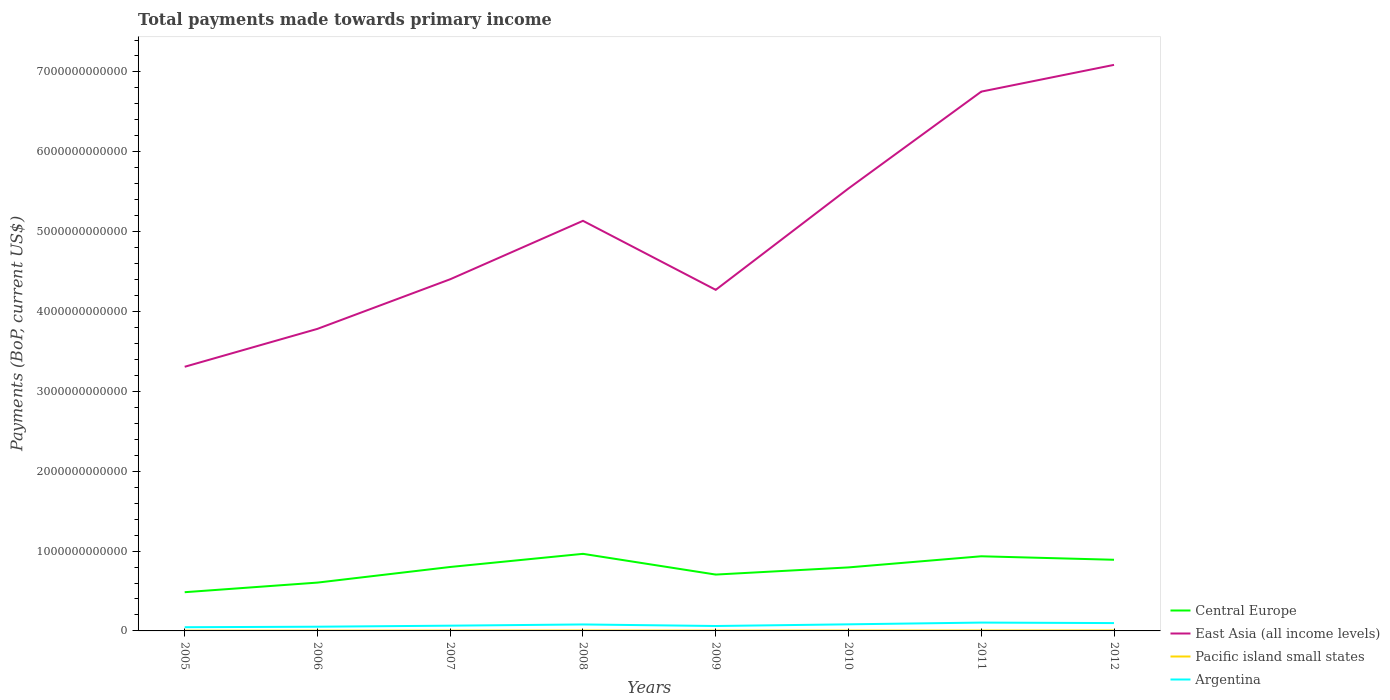Is the number of lines equal to the number of legend labels?
Make the answer very short. Yes. Across all years, what is the maximum total payments made towards primary income in Central Europe?
Offer a terse response. 4.85e+11. What is the total total payments made towards primary income in Pacific island small states in the graph?
Give a very brief answer. -1.23e+09. What is the difference between the highest and the second highest total payments made towards primary income in East Asia (all income levels)?
Your answer should be compact. 3.78e+12. What is the difference between two consecutive major ticks on the Y-axis?
Make the answer very short. 1.00e+12. Are the values on the major ticks of Y-axis written in scientific E-notation?
Your answer should be compact. No. Does the graph contain grids?
Provide a succinct answer. No. How many legend labels are there?
Make the answer very short. 4. What is the title of the graph?
Ensure brevity in your answer.  Total payments made towards primary income. Does "Cambodia" appear as one of the legend labels in the graph?
Make the answer very short. No. What is the label or title of the Y-axis?
Give a very brief answer. Payments (BoP, current US$). What is the Payments (BoP, current US$) in Central Europe in 2005?
Make the answer very short. 4.85e+11. What is the Payments (BoP, current US$) in East Asia (all income levels) in 2005?
Provide a short and direct response. 3.31e+12. What is the Payments (BoP, current US$) of Pacific island small states in 2005?
Provide a succinct answer. 3.59e+09. What is the Payments (BoP, current US$) of Argentina in 2005?
Offer a terse response. 4.64e+1. What is the Payments (BoP, current US$) in Central Europe in 2006?
Your answer should be very brief. 6.05e+11. What is the Payments (BoP, current US$) of East Asia (all income levels) in 2006?
Provide a succinct answer. 3.78e+12. What is the Payments (BoP, current US$) in Pacific island small states in 2006?
Make the answer very short. 3.94e+09. What is the Payments (BoP, current US$) of Argentina in 2006?
Your answer should be very brief. 5.28e+1. What is the Payments (BoP, current US$) of Central Europe in 2007?
Your response must be concise. 8.01e+11. What is the Payments (BoP, current US$) of East Asia (all income levels) in 2007?
Ensure brevity in your answer.  4.40e+12. What is the Payments (BoP, current US$) of Pacific island small states in 2007?
Provide a succinct answer. 4.20e+09. What is the Payments (BoP, current US$) of Argentina in 2007?
Offer a very short reply. 6.58e+1. What is the Payments (BoP, current US$) in Central Europe in 2008?
Your answer should be compact. 9.65e+11. What is the Payments (BoP, current US$) in East Asia (all income levels) in 2008?
Offer a terse response. 5.14e+12. What is the Payments (BoP, current US$) of Pacific island small states in 2008?
Give a very brief answer. 5.17e+09. What is the Payments (BoP, current US$) in Argentina in 2008?
Give a very brief answer. 8.10e+1. What is the Payments (BoP, current US$) in Central Europe in 2009?
Your answer should be compact. 7.06e+11. What is the Payments (BoP, current US$) in East Asia (all income levels) in 2009?
Provide a succinct answer. 4.27e+12. What is the Payments (BoP, current US$) in Pacific island small states in 2009?
Make the answer very short. 3.87e+09. What is the Payments (BoP, current US$) in Argentina in 2009?
Give a very brief answer. 6.17e+1. What is the Payments (BoP, current US$) in Central Europe in 2010?
Give a very brief answer. 7.95e+11. What is the Payments (BoP, current US$) of East Asia (all income levels) in 2010?
Offer a terse response. 5.54e+12. What is the Payments (BoP, current US$) in Pacific island small states in 2010?
Your answer should be compact. 4.63e+09. What is the Payments (BoP, current US$) of Argentina in 2010?
Offer a very short reply. 8.26e+1. What is the Payments (BoP, current US$) of Central Europe in 2011?
Keep it short and to the point. 9.35e+11. What is the Payments (BoP, current US$) of East Asia (all income levels) in 2011?
Offer a terse response. 6.75e+12. What is the Payments (BoP, current US$) of Pacific island small states in 2011?
Ensure brevity in your answer.  5.43e+09. What is the Payments (BoP, current US$) of Argentina in 2011?
Ensure brevity in your answer.  1.04e+11. What is the Payments (BoP, current US$) in Central Europe in 2012?
Offer a very short reply. 8.91e+11. What is the Payments (BoP, current US$) in East Asia (all income levels) in 2012?
Your answer should be compact. 7.09e+12. What is the Payments (BoP, current US$) of Pacific island small states in 2012?
Make the answer very short. 5.60e+09. What is the Payments (BoP, current US$) of Argentina in 2012?
Keep it short and to the point. 9.83e+1. Across all years, what is the maximum Payments (BoP, current US$) of Central Europe?
Ensure brevity in your answer.  9.65e+11. Across all years, what is the maximum Payments (BoP, current US$) in East Asia (all income levels)?
Your answer should be very brief. 7.09e+12. Across all years, what is the maximum Payments (BoP, current US$) in Pacific island small states?
Keep it short and to the point. 5.60e+09. Across all years, what is the maximum Payments (BoP, current US$) in Argentina?
Offer a terse response. 1.04e+11. Across all years, what is the minimum Payments (BoP, current US$) in Central Europe?
Offer a terse response. 4.85e+11. Across all years, what is the minimum Payments (BoP, current US$) in East Asia (all income levels)?
Ensure brevity in your answer.  3.31e+12. Across all years, what is the minimum Payments (BoP, current US$) in Pacific island small states?
Your response must be concise. 3.59e+09. Across all years, what is the minimum Payments (BoP, current US$) in Argentina?
Make the answer very short. 4.64e+1. What is the total Payments (BoP, current US$) of Central Europe in the graph?
Ensure brevity in your answer.  6.18e+12. What is the total Payments (BoP, current US$) in East Asia (all income levels) in the graph?
Provide a succinct answer. 4.03e+13. What is the total Payments (BoP, current US$) of Pacific island small states in the graph?
Offer a terse response. 3.64e+1. What is the total Payments (BoP, current US$) in Argentina in the graph?
Your answer should be very brief. 5.93e+11. What is the difference between the Payments (BoP, current US$) of Central Europe in 2005 and that in 2006?
Your answer should be very brief. -1.20e+11. What is the difference between the Payments (BoP, current US$) in East Asia (all income levels) in 2005 and that in 2006?
Your answer should be very brief. -4.75e+11. What is the difference between the Payments (BoP, current US$) of Pacific island small states in 2005 and that in 2006?
Offer a very short reply. -3.57e+08. What is the difference between the Payments (BoP, current US$) in Argentina in 2005 and that in 2006?
Your answer should be very brief. -6.39e+09. What is the difference between the Payments (BoP, current US$) of Central Europe in 2005 and that in 2007?
Your answer should be very brief. -3.16e+11. What is the difference between the Payments (BoP, current US$) of East Asia (all income levels) in 2005 and that in 2007?
Your answer should be very brief. -1.10e+12. What is the difference between the Payments (BoP, current US$) of Pacific island small states in 2005 and that in 2007?
Your answer should be compact. -6.11e+08. What is the difference between the Payments (BoP, current US$) in Argentina in 2005 and that in 2007?
Your answer should be very brief. -1.94e+1. What is the difference between the Payments (BoP, current US$) of Central Europe in 2005 and that in 2008?
Keep it short and to the point. -4.80e+11. What is the difference between the Payments (BoP, current US$) of East Asia (all income levels) in 2005 and that in 2008?
Offer a very short reply. -1.83e+12. What is the difference between the Payments (BoP, current US$) of Pacific island small states in 2005 and that in 2008?
Ensure brevity in your answer.  -1.58e+09. What is the difference between the Payments (BoP, current US$) in Argentina in 2005 and that in 2008?
Give a very brief answer. -3.46e+1. What is the difference between the Payments (BoP, current US$) of Central Europe in 2005 and that in 2009?
Provide a succinct answer. -2.21e+11. What is the difference between the Payments (BoP, current US$) of East Asia (all income levels) in 2005 and that in 2009?
Ensure brevity in your answer.  -9.63e+11. What is the difference between the Payments (BoP, current US$) of Pacific island small states in 2005 and that in 2009?
Provide a succinct answer. -2.79e+08. What is the difference between the Payments (BoP, current US$) in Argentina in 2005 and that in 2009?
Your answer should be very brief. -1.53e+1. What is the difference between the Payments (BoP, current US$) in Central Europe in 2005 and that in 2010?
Offer a very short reply. -3.10e+11. What is the difference between the Payments (BoP, current US$) in East Asia (all income levels) in 2005 and that in 2010?
Give a very brief answer. -2.23e+12. What is the difference between the Payments (BoP, current US$) in Pacific island small states in 2005 and that in 2010?
Ensure brevity in your answer.  -1.04e+09. What is the difference between the Payments (BoP, current US$) in Argentina in 2005 and that in 2010?
Offer a terse response. -3.62e+1. What is the difference between the Payments (BoP, current US$) in Central Europe in 2005 and that in 2011?
Offer a very short reply. -4.50e+11. What is the difference between the Payments (BoP, current US$) in East Asia (all income levels) in 2005 and that in 2011?
Keep it short and to the point. -3.45e+12. What is the difference between the Payments (BoP, current US$) in Pacific island small states in 2005 and that in 2011?
Your answer should be compact. -1.84e+09. What is the difference between the Payments (BoP, current US$) in Argentina in 2005 and that in 2011?
Your response must be concise. -5.80e+1. What is the difference between the Payments (BoP, current US$) of Central Europe in 2005 and that in 2012?
Ensure brevity in your answer.  -4.06e+11. What is the difference between the Payments (BoP, current US$) of East Asia (all income levels) in 2005 and that in 2012?
Offer a very short reply. -3.78e+12. What is the difference between the Payments (BoP, current US$) in Pacific island small states in 2005 and that in 2012?
Your answer should be compact. -2.02e+09. What is the difference between the Payments (BoP, current US$) of Argentina in 2005 and that in 2012?
Provide a short and direct response. -5.19e+1. What is the difference between the Payments (BoP, current US$) of Central Europe in 2006 and that in 2007?
Your answer should be very brief. -1.96e+11. What is the difference between the Payments (BoP, current US$) of East Asia (all income levels) in 2006 and that in 2007?
Ensure brevity in your answer.  -6.21e+11. What is the difference between the Payments (BoP, current US$) in Pacific island small states in 2006 and that in 2007?
Your answer should be compact. -2.54e+08. What is the difference between the Payments (BoP, current US$) of Argentina in 2006 and that in 2007?
Give a very brief answer. -1.30e+1. What is the difference between the Payments (BoP, current US$) of Central Europe in 2006 and that in 2008?
Ensure brevity in your answer.  -3.60e+11. What is the difference between the Payments (BoP, current US$) of East Asia (all income levels) in 2006 and that in 2008?
Offer a very short reply. -1.35e+12. What is the difference between the Payments (BoP, current US$) in Pacific island small states in 2006 and that in 2008?
Offer a very short reply. -1.22e+09. What is the difference between the Payments (BoP, current US$) in Argentina in 2006 and that in 2008?
Give a very brief answer. -2.82e+1. What is the difference between the Payments (BoP, current US$) of Central Europe in 2006 and that in 2009?
Keep it short and to the point. -1.01e+11. What is the difference between the Payments (BoP, current US$) of East Asia (all income levels) in 2006 and that in 2009?
Offer a terse response. -4.89e+11. What is the difference between the Payments (BoP, current US$) in Pacific island small states in 2006 and that in 2009?
Your answer should be compact. 7.80e+07. What is the difference between the Payments (BoP, current US$) in Argentina in 2006 and that in 2009?
Provide a succinct answer. -8.90e+09. What is the difference between the Payments (BoP, current US$) of Central Europe in 2006 and that in 2010?
Offer a very short reply. -1.90e+11. What is the difference between the Payments (BoP, current US$) of East Asia (all income levels) in 2006 and that in 2010?
Ensure brevity in your answer.  -1.76e+12. What is the difference between the Payments (BoP, current US$) of Pacific island small states in 2006 and that in 2010?
Your response must be concise. -6.84e+08. What is the difference between the Payments (BoP, current US$) of Argentina in 2006 and that in 2010?
Offer a very short reply. -2.98e+1. What is the difference between the Payments (BoP, current US$) of Central Europe in 2006 and that in 2011?
Offer a terse response. -3.30e+11. What is the difference between the Payments (BoP, current US$) in East Asia (all income levels) in 2006 and that in 2011?
Provide a succinct answer. -2.97e+12. What is the difference between the Payments (BoP, current US$) of Pacific island small states in 2006 and that in 2011?
Give a very brief answer. -1.48e+09. What is the difference between the Payments (BoP, current US$) in Argentina in 2006 and that in 2011?
Offer a terse response. -5.16e+1. What is the difference between the Payments (BoP, current US$) of Central Europe in 2006 and that in 2012?
Give a very brief answer. -2.86e+11. What is the difference between the Payments (BoP, current US$) of East Asia (all income levels) in 2006 and that in 2012?
Offer a terse response. -3.31e+12. What is the difference between the Payments (BoP, current US$) in Pacific island small states in 2006 and that in 2012?
Give a very brief answer. -1.66e+09. What is the difference between the Payments (BoP, current US$) in Argentina in 2006 and that in 2012?
Your answer should be compact. -4.55e+1. What is the difference between the Payments (BoP, current US$) of Central Europe in 2007 and that in 2008?
Offer a terse response. -1.65e+11. What is the difference between the Payments (BoP, current US$) of East Asia (all income levels) in 2007 and that in 2008?
Offer a very short reply. -7.32e+11. What is the difference between the Payments (BoP, current US$) in Pacific island small states in 2007 and that in 2008?
Ensure brevity in your answer.  -9.70e+08. What is the difference between the Payments (BoP, current US$) in Argentina in 2007 and that in 2008?
Provide a short and direct response. -1.52e+1. What is the difference between the Payments (BoP, current US$) of Central Europe in 2007 and that in 2009?
Offer a terse response. 9.51e+1. What is the difference between the Payments (BoP, current US$) of East Asia (all income levels) in 2007 and that in 2009?
Offer a very short reply. 1.33e+11. What is the difference between the Payments (BoP, current US$) in Pacific island small states in 2007 and that in 2009?
Give a very brief answer. 3.32e+08. What is the difference between the Payments (BoP, current US$) in Argentina in 2007 and that in 2009?
Give a very brief answer. 4.09e+09. What is the difference between the Payments (BoP, current US$) in Central Europe in 2007 and that in 2010?
Keep it short and to the point. 5.46e+09. What is the difference between the Payments (BoP, current US$) of East Asia (all income levels) in 2007 and that in 2010?
Give a very brief answer. -1.14e+12. What is the difference between the Payments (BoP, current US$) of Pacific island small states in 2007 and that in 2010?
Your response must be concise. -4.30e+08. What is the difference between the Payments (BoP, current US$) in Argentina in 2007 and that in 2010?
Provide a succinct answer. -1.68e+1. What is the difference between the Payments (BoP, current US$) of Central Europe in 2007 and that in 2011?
Offer a very short reply. -1.34e+11. What is the difference between the Payments (BoP, current US$) of East Asia (all income levels) in 2007 and that in 2011?
Offer a terse response. -2.35e+12. What is the difference between the Payments (BoP, current US$) in Pacific island small states in 2007 and that in 2011?
Ensure brevity in your answer.  -1.23e+09. What is the difference between the Payments (BoP, current US$) in Argentina in 2007 and that in 2011?
Offer a very short reply. -3.86e+1. What is the difference between the Payments (BoP, current US$) in Central Europe in 2007 and that in 2012?
Give a very brief answer. -9.03e+1. What is the difference between the Payments (BoP, current US$) of East Asia (all income levels) in 2007 and that in 2012?
Make the answer very short. -2.68e+12. What is the difference between the Payments (BoP, current US$) in Pacific island small states in 2007 and that in 2012?
Offer a terse response. -1.41e+09. What is the difference between the Payments (BoP, current US$) in Argentina in 2007 and that in 2012?
Ensure brevity in your answer.  -3.25e+1. What is the difference between the Payments (BoP, current US$) of Central Europe in 2008 and that in 2009?
Offer a very short reply. 2.60e+11. What is the difference between the Payments (BoP, current US$) of East Asia (all income levels) in 2008 and that in 2009?
Offer a terse response. 8.64e+11. What is the difference between the Payments (BoP, current US$) in Pacific island small states in 2008 and that in 2009?
Ensure brevity in your answer.  1.30e+09. What is the difference between the Payments (BoP, current US$) in Argentina in 2008 and that in 2009?
Your answer should be compact. 1.93e+1. What is the difference between the Payments (BoP, current US$) of Central Europe in 2008 and that in 2010?
Your answer should be compact. 1.70e+11. What is the difference between the Payments (BoP, current US$) of East Asia (all income levels) in 2008 and that in 2010?
Give a very brief answer. -4.05e+11. What is the difference between the Payments (BoP, current US$) in Pacific island small states in 2008 and that in 2010?
Make the answer very short. 5.40e+08. What is the difference between the Payments (BoP, current US$) in Argentina in 2008 and that in 2010?
Ensure brevity in your answer.  -1.59e+09. What is the difference between the Payments (BoP, current US$) in Central Europe in 2008 and that in 2011?
Provide a succinct answer. 3.06e+1. What is the difference between the Payments (BoP, current US$) in East Asia (all income levels) in 2008 and that in 2011?
Your answer should be compact. -1.62e+12. What is the difference between the Payments (BoP, current US$) in Pacific island small states in 2008 and that in 2011?
Make the answer very short. -2.60e+08. What is the difference between the Payments (BoP, current US$) in Argentina in 2008 and that in 2011?
Provide a short and direct response. -2.34e+1. What is the difference between the Payments (BoP, current US$) of Central Europe in 2008 and that in 2012?
Offer a very short reply. 7.43e+1. What is the difference between the Payments (BoP, current US$) in East Asia (all income levels) in 2008 and that in 2012?
Ensure brevity in your answer.  -1.95e+12. What is the difference between the Payments (BoP, current US$) in Pacific island small states in 2008 and that in 2012?
Ensure brevity in your answer.  -4.36e+08. What is the difference between the Payments (BoP, current US$) of Argentina in 2008 and that in 2012?
Your response must be concise. -1.73e+1. What is the difference between the Payments (BoP, current US$) in Central Europe in 2009 and that in 2010?
Your answer should be compact. -8.97e+1. What is the difference between the Payments (BoP, current US$) in East Asia (all income levels) in 2009 and that in 2010?
Keep it short and to the point. -1.27e+12. What is the difference between the Payments (BoP, current US$) of Pacific island small states in 2009 and that in 2010?
Your answer should be very brief. -7.62e+08. What is the difference between the Payments (BoP, current US$) in Argentina in 2009 and that in 2010?
Provide a short and direct response. -2.09e+1. What is the difference between the Payments (BoP, current US$) in Central Europe in 2009 and that in 2011?
Provide a succinct answer. -2.29e+11. What is the difference between the Payments (BoP, current US$) in East Asia (all income levels) in 2009 and that in 2011?
Provide a short and direct response. -2.48e+12. What is the difference between the Payments (BoP, current US$) of Pacific island small states in 2009 and that in 2011?
Your answer should be compact. -1.56e+09. What is the difference between the Payments (BoP, current US$) of Argentina in 2009 and that in 2011?
Offer a terse response. -4.27e+1. What is the difference between the Payments (BoP, current US$) in Central Europe in 2009 and that in 2012?
Give a very brief answer. -1.85e+11. What is the difference between the Payments (BoP, current US$) in East Asia (all income levels) in 2009 and that in 2012?
Make the answer very short. -2.82e+12. What is the difference between the Payments (BoP, current US$) in Pacific island small states in 2009 and that in 2012?
Make the answer very short. -1.74e+09. What is the difference between the Payments (BoP, current US$) in Argentina in 2009 and that in 2012?
Your answer should be very brief. -3.66e+1. What is the difference between the Payments (BoP, current US$) of Central Europe in 2010 and that in 2011?
Offer a very short reply. -1.39e+11. What is the difference between the Payments (BoP, current US$) in East Asia (all income levels) in 2010 and that in 2011?
Ensure brevity in your answer.  -1.21e+12. What is the difference between the Payments (BoP, current US$) in Pacific island small states in 2010 and that in 2011?
Keep it short and to the point. -8.00e+08. What is the difference between the Payments (BoP, current US$) of Argentina in 2010 and that in 2011?
Give a very brief answer. -2.18e+1. What is the difference between the Payments (BoP, current US$) in Central Europe in 2010 and that in 2012?
Provide a short and direct response. -9.57e+1. What is the difference between the Payments (BoP, current US$) in East Asia (all income levels) in 2010 and that in 2012?
Make the answer very short. -1.55e+12. What is the difference between the Payments (BoP, current US$) of Pacific island small states in 2010 and that in 2012?
Your answer should be very brief. -9.76e+08. What is the difference between the Payments (BoP, current US$) of Argentina in 2010 and that in 2012?
Your answer should be very brief. -1.57e+1. What is the difference between the Payments (BoP, current US$) in Central Europe in 2011 and that in 2012?
Keep it short and to the point. 4.37e+1. What is the difference between the Payments (BoP, current US$) in East Asia (all income levels) in 2011 and that in 2012?
Offer a terse response. -3.35e+11. What is the difference between the Payments (BoP, current US$) of Pacific island small states in 2011 and that in 2012?
Provide a succinct answer. -1.75e+08. What is the difference between the Payments (BoP, current US$) of Argentina in 2011 and that in 2012?
Provide a succinct answer. 6.14e+09. What is the difference between the Payments (BoP, current US$) in Central Europe in 2005 and the Payments (BoP, current US$) in East Asia (all income levels) in 2006?
Give a very brief answer. -3.30e+12. What is the difference between the Payments (BoP, current US$) of Central Europe in 2005 and the Payments (BoP, current US$) of Pacific island small states in 2006?
Your response must be concise. 4.81e+11. What is the difference between the Payments (BoP, current US$) in Central Europe in 2005 and the Payments (BoP, current US$) in Argentina in 2006?
Your answer should be very brief. 4.32e+11. What is the difference between the Payments (BoP, current US$) in East Asia (all income levels) in 2005 and the Payments (BoP, current US$) in Pacific island small states in 2006?
Offer a very short reply. 3.30e+12. What is the difference between the Payments (BoP, current US$) of East Asia (all income levels) in 2005 and the Payments (BoP, current US$) of Argentina in 2006?
Your response must be concise. 3.26e+12. What is the difference between the Payments (BoP, current US$) of Pacific island small states in 2005 and the Payments (BoP, current US$) of Argentina in 2006?
Your answer should be compact. -4.92e+1. What is the difference between the Payments (BoP, current US$) of Central Europe in 2005 and the Payments (BoP, current US$) of East Asia (all income levels) in 2007?
Ensure brevity in your answer.  -3.92e+12. What is the difference between the Payments (BoP, current US$) in Central Europe in 2005 and the Payments (BoP, current US$) in Pacific island small states in 2007?
Provide a short and direct response. 4.81e+11. What is the difference between the Payments (BoP, current US$) of Central Europe in 2005 and the Payments (BoP, current US$) of Argentina in 2007?
Provide a short and direct response. 4.19e+11. What is the difference between the Payments (BoP, current US$) of East Asia (all income levels) in 2005 and the Payments (BoP, current US$) of Pacific island small states in 2007?
Offer a very short reply. 3.30e+12. What is the difference between the Payments (BoP, current US$) of East Asia (all income levels) in 2005 and the Payments (BoP, current US$) of Argentina in 2007?
Ensure brevity in your answer.  3.24e+12. What is the difference between the Payments (BoP, current US$) of Pacific island small states in 2005 and the Payments (BoP, current US$) of Argentina in 2007?
Provide a short and direct response. -6.22e+1. What is the difference between the Payments (BoP, current US$) in Central Europe in 2005 and the Payments (BoP, current US$) in East Asia (all income levels) in 2008?
Your answer should be compact. -4.65e+12. What is the difference between the Payments (BoP, current US$) of Central Europe in 2005 and the Payments (BoP, current US$) of Pacific island small states in 2008?
Your response must be concise. 4.80e+11. What is the difference between the Payments (BoP, current US$) of Central Europe in 2005 and the Payments (BoP, current US$) of Argentina in 2008?
Provide a succinct answer. 4.04e+11. What is the difference between the Payments (BoP, current US$) in East Asia (all income levels) in 2005 and the Payments (BoP, current US$) in Pacific island small states in 2008?
Ensure brevity in your answer.  3.30e+12. What is the difference between the Payments (BoP, current US$) of East Asia (all income levels) in 2005 and the Payments (BoP, current US$) of Argentina in 2008?
Make the answer very short. 3.23e+12. What is the difference between the Payments (BoP, current US$) of Pacific island small states in 2005 and the Payments (BoP, current US$) of Argentina in 2008?
Give a very brief answer. -7.74e+1. What is the difference between the Payments (BoP, current US$) in Central Europe in 2005 and the Payments (BoP, current US$) in East Asia (all income levels) in 2009?
Ensure brevity in your answer.  -3.79e+12. What is the difference between the Payments (BoP, current US$) of Central Europe in 2005 and the Payments (BoP, current US$) of Pacific island small states in 2009?
Offer a very short reply. 4.81e+11. What is the difference between the Payments (BoP, current US$) in Central Europe in 2005 and the Payments (BoP, current US$) in Argentina in 2009?
Offer a terse response. 4.23e+11. What is the difference between the Payments (BoP, current US$) of East Asia (all income levels) in 2005 and the Payments (BoP, current US$) of Pacific island small states in 2009?
Your answer should be compact. 3.30e+12. What is the difference between the Payments (BoP, current US$) in East Asia (all income levels) in 2005 and the Payments (BoP, current US$) in Argentina in 2009?
Your answer should be very brief. 3.25e+12. What is the difference between the Payments (BoP, current US$) of Pacific island small states in 2005 and the Payments (BoP, current US$) of Argentina in 2009?
Your answer should be compact. -5.81e+1. What is the difference between the Payments (BoP, current US$) of Central Europe in 2005 and the Payments (BoP, current US$) of East Asia (all income levels) in 2010?
Keep it short and to the point. -5.06e+12. What is the difference between the Payments (BoP, current US$) in Central Europe in 2005 and the Payments (BoP, current US$) in Pacific island small states in 2010?
Provide a succinct answer. 4.80e+11. What is the difference between the Payments (BoP, current US$) in Central Europe in 2005 and the Payments (BoP, current US$) in Argentina in 2010?
Your answer should be compact. 4.02e+11. What is the difference between the Payments (BoP, current US$) of East Asia (all income levels) in 2005 and the Payments (BoP, current US$) of Pacific island small states in 2010?
Ensure brevity in your answer.  3.30e+12. What is the difference between the Payments (BoP, current US$) in East Asia (all income levels) in 2005 and the Payments (BoP, current US$) in Argentina in 2010?
Give a very brief answer. 3.23e+12. What is the difference between the Payments (BoP, current US$) of Pacific island small states in 2005 and the Payments (BoP, current US$) of Argentina in 2010?
Your answer should be very brief. -7.90e+1. What is the difference between the Payments (BoP, current US$) in Central Europe in 2005 and the Payments (BoP, current US$) in East Asia (all income levels) in 2011?
Give a very brief answer. -6.27e+12. What is the difference between the Payments (BoP, current US$) in Central Europe in 2005 and the Payments (BoP, current US$) in Pacific island small states in 2011?
Your response must be concise. 4.79e+11. What is the difference between the Payments (BoP, current US$) in Central Europe in 2005 and the Payments (BoP, current US$) in Argentina in 2011?
Offer a terse response. 3.80e+11. What is the difference between the Payments (BoP, current US$) in East Asia (all income levels) in 2005 and the Payments (BoP, current US$) in Pacific island small states in 2011?
Offer a terse response. 3.30e+12. What is the difference between the Payments (BoP, current US$) of East Asia (all income levels) in 2005 and the Payments (BoP, current US$) of Argentina in 2011?
Offer a very short reply. 3.20e+12. What is the difference between the Payments (BoP, current US$) of Pacific island small states in 2005 and the Payments (BoP, current US$) of Argentina in 2011?
Your response must be concise. -1.01e+11. What is the difference between the Payments (BoP, current US$) of Central Europe in 2005 and the Payments (BoP, current US$) of East Asia (all income levels) in 2012?
Give a very brief answer. -6.60e+12. What is the difference between the Payments (BoP, current US$) of Central Europe in 2005 and the Payments (BoP, current US$) of Pacific island small states in 2012?
Make the answer very short. 4.79e+11. What is the difference between the Payments (BoP, current US$) in Central Europe in 2005 and the Payments (BoP, current US$) in Argentina in 2012?
Your response must be concise. 3.87e+11. What is the difference between the Payments (BoP, current US$) of East Asia (all income levels) in 2005 and the Payments (BoP, current US$) of Pacific island small states in 2012?
Your response must be concise. 3.30e+12. What is the difference between the Payments (BoP, current US$) in East Asia (all income levels) in 2005 and the Payments (BoP, current US$) in Argentina in 2012?
Your answer should be compact. 3.21e+12. What is the difference between the Payments (BoP, current US$) of Pacific island small states in 2005 and the Payments (BoP, current US$) of Argentina in 2012?
Provide a short and direct response. -9.47e+1. What is the difference between the Payments (BoP, current US$) of Central Europe in 2006 and the Payments (BoP, current US$) of East Asia (all income levels) in 2007?
Provide a succinct answer. -3.80e+12. What is the difference between the Payments (BoP, current US$) in Central Europe in 2006 and the Payments (BoP, current US$) in Pacific island small states in 2007?
Offer a very short reply. 6.01e+11. What is the difference between the Payments (BoP, current US$) in Central Europe in 2006 and the Payments (BoP, current US$) in Argentina in 2007?
Give a very brief answer. 5.39e+11. What is the difference between the Payments (BoP, current US$) of East Asia (all income levels) in 2006 and the Payments (BoP, current US$) of Pacific island small states in 2007?
Offer a very short reply. 3.78e+12. What is the difference between the Payments (BoP, current US$) of East Asia (all income levels) in 2006 and the Payments (BoP, current US$) of Argentina in 2007?
Your answer should be compact. 3.72e+12. What is the difference between the Payments (BoP, current US$) in Pacific island small states in 2006 and the Payments (BoP, current US$) in Argentina in 2007?
Offer a very short reply. -6.18e+1. What is the difference between the Payments (BoP, current US$) of Central Europe in 2006 and the Payments (BoP, current US$) of East Asia (all income levels) in 2008?
Offer a very short reply. -4.53e+12. What is the difference between the Payments (BoP, current US$) of Central Europe in 2006 and the Payments (BoP, current US$) of Pacific island small states in 2008?
Ensure brevity in your answer.  6.00e+11. What is the difference between the Payments (BoP, current US$) in Central Europe in 2006 and the Payments (BoP, current US$) in Argentina in 2008?
Make the answer very short. 5.24e+11. What is the difference between the Payments (BoP, current US$) in East Asia (all income levels) in 2006 and the Payments (BoP, current US$) in Pacific island small states in 2008?
Keep it short and to the point. 3.78e+12. What is the difference between the Payments (BoP, current US$) in East Asia (all income levels) in 2006 and the Payments (BoP, current US$) in Argentina in 2008?
Your answer should be very brief. 3.70e+12. What is the difference between the Payments (BoP, current US$) in Pacific island small states in 2006 and the Payments (BoP, current US$) in Argentina in 2008?
Provide a succinct answer. -7.71e+1. What is the difference between the Payments (BoP, current US$) of Central Europe in 2006 and the Payments (BoP, current US$) of East Asia (all income levels) in 2009?
Ensure brevity in your answer.  -3.67e+12. What is the difference between the Payments (BoP, current US$) in Central Europe in 2006 and the Payments (BoP, current US$) in Pacific island small states in 2009?
Ensure brevity in your answer.  6.01e+11. What is the difference between the Payments (BoP, current US$) in Central Europe in 2006 and the Payments (BoP, current US$) in Argentina in 2009?
Offer a terse response. 5.43e+11. What is the difference between the Payments (BoP, current US$) in East Asia (all income levels) in 2006 and the Payments (BoP, current US$) in Pacific island small states in 2009?
Provide a succinct answer. 3.78e+12. What is the difference between the Payments (BoP, current US$) in East Asia (all income levels) in 2006 and the Payments (BoP, current US$) in Argentina in 2009?
Your answer should be compact. 3.72e+12. What is the difference between the Payments (BoP, current US$) of Pacific island small states in 2006 and the Payments (BoP, current US$) of Argentina in 2009?
Give a very brief answer. -5.78e+1. What is the difference between the Payments (BoP, current US$) of Central Europe in 2006 and the Payments (BoP, current US$) of East Asia (all income levels) in 2010?
Offer a very short reply. -4.94e+12. What is the difference between the Payments (BoP, current US$) in Central Europe in 2006 and the Payments (BoP, current US$) in Pacific island small states in 2010?
Make the answer very short. 6.01e+11. What is the difference between the Payments (BoP, current US$) in Central Europe in 2006 and the Payments (BoP, current US$) in Argentina in 2010?
Make the answer very short. 5.23e+11. What is the difference between the Payments (BoP, current US$) in East Asia (all income levels) in 2006 and the Payments (BoP, current US$) in Pacific island small states in 2010?
Your answer should be very brief. 3.78e+12. What is the difference between the Payments (BoP, current US$) of East Asia (all income levels) in 2006 and the Payments (BoP, current US$) of Argentina in 2010?
Your answer should be very brief. 3.70e+12. What is the difference between the Payments (BoP, current US$) of Pacific island small states in 2006 and the Payments (BoP, current US$) of Argentina in 2010?
Provide a short and direct response. -7.87e+1. What is the difference between the Payments (BoP, current US$) in Central Europe in 2006 and the Payments (BoP, current US$) in East Asia (all income levels) in 2011?
Give a very brief answer. -6.15e+12. What is the difference between the Payments (BoP, current US$) of Central Europe in 2006 and the Payments (BoP, current US$) of Pacific island small states in 2011?
Your answer should be very brief. 6.00e+11. What is the difference between the Payments (BoP, current US$) of Central Europe in 2006 and the Payments (BoP, current US$) of Argentina in 2011?
Provide a short and direct response. 5.01e+11. What is the difference between the Payments (BoP, current US$) of East Asia (all income levels) in 2006 and the Payments (BoP, current US$) of Pacific island small states in 2011?
Your answer should be very brief. 3.78e+12. What is the difference between the Payments (BoP, current US$) of East Asia (all income levels) in 2006 and the Payments (BoP, current US$) of Argentina in 2011?
Give a very brief answer. 3.68e+12. What is the difference between the Payments (BoP, current US$) in Pacific island small states in 2006 and the Payments (BoP, current US$) in Argentina in 2011?
Offer a very short reply. -1.00e+11. What is the difference between the Payments (BoP, current US$) in Central Europe in 2006 and the Payments (BoP, current US$) in East Asia (all income levels) in 2012?
Provide a short and direct response. -6.48e+12. What is the difference between the Payments (BoP, current US$) of Central Europe in 2006 and the Payments (BoP, current US$) of Pacific island small states in 2012?
Offer a terse response. 6.00e+11. What is the difference between the Payments (BoP, current US$) in Central Europe in 2006 and the Payments (BoP, current US$) in Argentina in 2012?
Give a very brief answer. 5.07e+11. What is the difference between the Payments (BoP, current US$) in East Asia (all income levels) in 2006 and the Payments (BoP, current US$) in Pacific island small states in 2012?
Your answer should be compact. 3.78e+12. What is the difference between the Payments (BoP, current US$) of East Asia (all income levels) in 2006 and the Payments (BoP, current US$) of Argentina in 2012?
Keep it short and to the point. 3.68e+12. What is the difference between the Payments (BoP, current US$) in Pacific island small states in 2006 and the Payments (BoP, current US$) in Argentina in 2012?
Offer a very short reply. -9.43e+1. What is the difference between the Payments (BoP, current US$) of Central Europe in 2007 and the Payments (BoP, current US$) of East Asia (all income levels) in 2008?
Offer a very short reply. -4.33e+12. What is the difference between the Payments (BoP, current US$) in Central Europe in 2007 and the Payments (BoP, current US$) in Pacific island small states in 2008?
Provide a short and direct response. 7.96e+11. What is the difference between the Payments (BoP, current US$) in Central Europe in 2007 and the Payments (BoP, current US$) in Argentina in 2008?
Provide a short and direct response. 7.20e+11. What is the difference between the Payments (BoP, current US$) of East Asia (all income levels) in 2007 and the Payments (BoP, current US$) of Pacific island small states in 2008?
Give a very brief answer. 4.40e+12. What is the difference between the Payments (BoP, current US$) in East Asia (all income levels) in 2007 and the Payments (BoP, current US$) in Argentina in 2008?
Your answer should be very brief. 4.32e+12. What is the difference between the Payments (BoP, current US$) of Pacific island small states in 2007 and the Payments (BoP, current US$) of Argentina in 2008?
Provide a succinct answer. -7.68e+1. What is the difference between the Payments (BoP, current US$) in Central Europe in 2007 and the Payments (BoP, current US$) in East Asia (all income levels) in 2009?
Offer a terse response. -3.47e+12. What is the difference between the Payments (BoP, current US$) in Central Europe in 2007 and the Payments (BoP, current US$) in Pacific island small states in 2009?
Keep it short and to the point. 7.97e+11. What is the difference between the Payments (BoP, current US$) in Central Europe in 2007 and the Payments (BoP, current US$) in Argentina in 2009?
Provide a short and direct response. 7.39e+11. What is the difference between the Payments (BoP, current US$) of East Asia (all income levels) in 2007 and the Payments (BoP, current US$) of Pacific island small states in 2009?
Provide a succinct answer. 4.40e+12. What is the difference between the Payments (BoP, current US$) of East Asia (all income levels) in 2007 and the Payments (BoP, current US$) of Argentina in 2009?
Provide a succinct answer. 4.34e+12. What is the difference between the Payments (BoP, current US$) of Pacific island small states in 2007 and the Payments (BoP, current US$) of Argentina in 2009?
Provide a succinct answer. -5.75e+1. What is the difference between the Payments (BoP, current US$) of Central Europe in 2007 and the Payments (BoP, current US$) of East Asia (all income levels) in 2010?
Your answer should be very brief. -4.74e+12. What is the difference between the Payments (BoP, current US$) of Central Europe in 2007 and the Payments (BoP, current US$) of Pacific island small states in 2010?
Give a very brief answer. 7.96e+11. What is the difference between the Payments (BoP, current US$) in Central Europe in 2007 and the Payments (BoP, current US$) in Argentina in 2010?
Give a very brief answer. 7.18e+11. What is the difference between the Payments (BoP, current US$) in East Asia (all income levels) in 2007 and the Payments (BoP, current US$) in Pacific island small states in 2010?
Ensure brevity in your answer.  4.40e+12. What is the difference between the Payments (BoP, current US$) in East Asia (all income levels) in 2007 and the Payments (BoP, current US$) in Argentina in 2010?
Your answer should be compact. 4.32e+12. What is the difference between the Payments (BoP, current US$) in Pacific island small states in 2007 and the Payments (BoP, current US$) in Argentina in 2010?
Your answer should be compact. -7.84e+1. What is the difference between the Payments (BoP, current US$) of Central Europe in 2007 and the Payments (BoP, current US$) of East Asia (all income levels) in 2011?
Offer a very short reply. -5.95e+12. What is the difference between the Payments (BoP, current US$) in Central Europe in 2007 and the Payments (BoP, current US$) in Pacific island small states in 2011?
Offer a terse response. 7.95e+11. What is the difference between the Payments (BoP, current US$) of Central Europe in 2007 and the Payments (BoP, current US$) of Argentina in 2011?
Offer a terse response. 6.96e+11. What is the difference between the Payments (BoP, current US$) of East Asia (all income levels) in 2007 and the Payments (BoP, current US$) of Pacific island small states in 2011?
Your answer should be very brief. 4.40e+12. What is the difference between the Payments (BoP, current US$) of East Asia (all income levels) in 2007 and the Payments (BoP, current US$) of Argentina in 2011?
Offer a terse response. 4.30e+12. What is the difference between the Payments (BoP, current US$) of Pacific island small states in 2007 and the Payments (BoP, current US$) of Argentina in 2011?
Ensure brevity in your answer.  -1.00e+11. What is the difference between the Payments (BoP, current US$) of Central Europe in 2007 and the Payments (BoP, current US$) of East Asia (all income levels) in 2012?
Your response must be concise. -6.29e+12. What is the difference between the Payments (BoP, current US$) in Central Europe in 2007 and the Payments (BoP, current US$) in Pacific island small states in 2012?
Make the answer very short. 7.95e+11. What is the difference between the Payments (BoP, current US$) in Central Europe in 2007 and the Payments (BoP, current US$) in Argentina in 2012?
Make the answer very short. 7.03e+11. What is the difference between the Payments (BoP, current US$) of East Asia (all income levels) in 2007 and the Payments (BoP, current US$) of Pacific island small states in 2012?
Keep it short and to the point. 4.40e+12. What is the difference between the Payments (BoP, current US$) of East Asia (all income levels) in 2007 and the Payments (BoP, current US$) of Argentina in 2012?
Keep it short and to the point. 4.31e+12. What is the difference between the Payments (BoP, current US$) in Pacific island small states in 2007 and the Payments (BoP, current US$) in Argentina in 2012?
Your answer should be very brief. -9.41e+1. What is the difference between the Payments (BoP, current US$) in Central Europe in 2008 and the Payments (BoP, current US$) in East Asia (all income levels) in 2009?
Provide a short and direct response. -3.31e+12. What is the difference between the Payments (BoP, current US$) in Central Europe in 2008 and the Payments (BoP, current US$) in Pacific island small states in 2009?
Give a very brief answer. 9.62e+11. What is the difference between the Payments (BoP, current US$) in Central Europe in 2008 and the Payments (BoP, current US$) in Argentina in 2009?
Ensure brevity in your answer.  9.04e+11. What is the difference between the Payments (BoP, current US$) of East Asia (all income levels) in 2008 and the Payments (BoP, current US$) of Pacific island small states in 2009?
Your answer should be very brief. 5.13e+12. What is the difference between the Payments (BoP, current US$) in East Asia (all income levels) in 2008 and the Payments (BoP, current US$) in Argentina in 2009?
Your response must be concise. 5.07e+12. What is the difference between the Payments (BoP, current US$) of Pacific island small states in 2008 and the Payments (BoP, current US$) of Argentina in 2009?
Your response must be concise. -5.65e+1. What is the difference between the Payments (BoP, current US$) of Central Europe in 2008 and the Payments (BoP, current US$) of East Asia (all income levels) in 2010?
Ensure brevity in your answer.  -4.58e+12. What is the difference between the Payments (BoP, current US$) of Central Europe in 2008 and the Payments (BoP, current US$) of Pacific island small states in 2010?
Give a very brief answer. 9.61e+11. What is the difference between the Payments (BoP, current US$) of Central Europe in 2008 and the Payments (BoP, current US$) of Argentina in 2010?
Provide a succinct answer. 8.83e+11. What is the difference between the Payments (BoP, current US$) in East Asia (all income levels) in 2008 and the Payments (BoP, current US$) in Pacific island small states in 2010?
Offer a terse response. 5.13e+12. What is the difference between the Payments (BoP, current US$) of East Asia (all income levels) in 2008 and the Payments (BoP, current US$) of Argentina in 2010?
Give a very brief answer. 5.05e+12. What is the difference between the Payments (BoP, current US$) in Pacific island small states in 2008 and the Payments (BoP, current US$) in Argentina in 2010?
Ensure brevity in your answer.  -7.74e+1. What is the difference between the Payments (BoP, current US$) of Central Europe in 2008 and the Payments (BoP, current US$) of East Asia (all income levels) in 2011?
Provide a short and direct response. -5.79e+12. What is the difference between the Payments (BoP, current US$) of Central Europe in 2008 and the Payments (BoP, current US$) of Pacific island small states in 2011?
Provide a short and direct response. 9.60e+11. What is the difference between the Payments (BoP, current US$) of Central Europe in 2008 and the Payments (BoP, current US$) of Argentina in 2011?
Ensure brevity in your answer.  8.61e+11. What is the difference between the Payments (BoP, current US$) of East Asia (all income levels) in 2008 and the Payments (BoP, current US$) of Pacific island small states in 2011?
Give a very brief answer. 5.13e+12. What is the difference between the Payments (BoP, current US$) in East Asia (all income levels) in 2008 and the Payments (BoP, current US$) in Argentina in 2011?
Make the answer very short. 5.03e+12. What is the difference between the Payments (BoP, current US$) of Pacific island small states in 2008 and the Payments (BoP, current US$) of Argentina in 2011?
Give a very brief answer. -9.93e+1. What is the difference between the Payments (BoP, current US$) in Central Europe in 2008 and the Payments (BoP, current US$) in East Asia (all income levels) in 2012?
Offer a very short reply. -6.12e+12. What is the difference between the Payments (BoP, current US$) of Central Europe in 2008 and the Payments (BoP, current US$) of Pacific island small states in 2012?
Give a very brief answer. 9.60e+11. What is the difference between the Payments (BoP, current US$) of Central Europe in 2008 and the Payments (BoP, current US$) of Argentina in 2012?
Your answer should be very brief. 8.67e+11. What is the difference between the Payments (BoP, current US$) of East Asia (all income levels) in 2008 and the Payments (BoP, current US$) of Pacific island small states in 2012?
Provide a succinct answer. 5.13e+12. What is the difference between the Payments (BoP, current US$) of East Asia (all income levels) in 2008 and the Payments (BoP, current US$) of Argentina in 2012?
Offer a terse response. 5.04e+12. What is the difference between the Payments (BoP, current US$) of Pacific island small states in 2008 and the Payments (BoP, current US$) of Argentina in 2012?
Offer a terse response. -9.31e+1. What is the difference between the Payments (BoP, current US$) in Central Europe in 2009 and the Payments (BoP, current US$) in East Asia (all income levels) in 2010?
Offer a terse response. -4.84e+12. What is the difference between the Payments (BoP, current US$) of Central Europe in 2009 and the Payments (BoP, current US$) of Pacific island small states in 2010?
Your answer should be very brief. 7.01e+11. What is the difference between the Payments (BoP, current US$) of Central Europe in 2009 and the Payments (BoP, current US$) of Argentina in 2010?
Offer a terse response. 6.23e+11. What is the difference between the Payments (BoP, current US$) of East Asia (all income levels) in 2009 and the Payments (BoP, current US$) of Pacific island small states in 2010?
Give a very brief answer. 4.27e+12. What is the difference between the Payments (BoP, current US$) of East Asia (all income levels) in 2009 and the Payments (BoP, current US$) of Argentina in 2010?
Ensure brevity in your answer.  4.19e+12. What is the difference between the Payments (BoP, current US$) of Pacific island small states in 2009 and the Payments (BoP, current US$) of Argentina in 2010?
Your response must be concise. -7.87e+1. What is the difference between the Payments (BoP, current US$) of Central Europe in 2009 and the Payments (BoP, current US$) of East Asia (all income levels) in 2011?
Make the answer very short. -6.05e+12. What is the difference between the Payments (BoP, current US$) of Central Europe in 2009 and the Payments (BoP, current US$) of Pacific island small states in 2011?
Keep it short and to the point. 7.00e+11. What is the difference between the Payments (BoP, current US$) of Central Europe in 2009 and the Payments (BoP, current US$) of Argentina in 2011?
Offer a terse response. 6.01e+11. What is the difference between the Payments (BoP, current US$) in East Asia (all income levels) in 2009 and the Payments (BoP, current US$) in Pacific island small states in 2011?
Make the answer very short. 4.27e+12. What is the difference between the Payments (BoP, current US$) in East Asia (all income levels) in 2009 and the Payments (BoP, current US$) in Argentina in 2011?
Provide a short and direct response. 4.17e+12. What is the difference between the Payments (BoP, current US$) of Pacific island small states in 2009 and the Payments (BoP, current US$) of Argentina in 2011?
Provide a succinct answer. -1.01e+11. What is the difference between the Payments (BoP, current US$) of Central Europe in 2009 and the Payments (BoP, current US$) of East Asia (all income levels) in 2012?
Your answer should be compact. -6.38e+12. What is the difference between the Payments (BoP, current US$) of Central Europe in 2009 and the Payments (BoP, current US$) of Pacific island small states in 2012?
Provide a succinct answer. 7.00e+11. What is the difference between the Payments (BoP, current US$) of Central Europe in 2009 and the Payments (BoP, current US$) of Argentina in 2012?
Offer a terse response. 6.07e+11. What is the difference between the Payments (BoP, current US$) of East Asia (all income levels) in 2009 and the Payments (BoP, current US$) of Pacific island small states in 2012?
Your answer should be compact. 4.27e+12. What is the difference between the Payments (BoP, current US$) in East Asia (all income levels) in 2009 and the Payments (BoP, current US$) in Argentina in 2012?
Offer a very short reply. 4.17e+12. What is the difference between the Payments (BoP, current US$) of Pacific island small states in 2009 and the Payments (BoP, current US$) of Argentina in 2012?
Give a very brief answer. -9.44e+1. What is the difference between the Payments (BoP, current US$) in Central Europe in 2010 and the Payments (BoP, current US$) in East Asia (all income levels) in 2011?
Your answer should be very brief. -5.96e+12. What is the difference between the Payments (BoP, current US$) in Central Europe in 2010 and the Payments (BoP, current US$) in Pacific island small states in 2011?
Offer a very short reply. 7.90e+11. What is the difference between the Payments (BoP, current US$) in Central Europe in 2010 and the Payments (BoP, current US$) in Argentina in 2011?
Provide a succinct answer. 6.91e+11. What is the difference between the Payments (BoP, current US$) of East Asia (all income levels) in 2010 and the Payments (BoP, current US$) of Pacific island small states in 2011?
Your answer should be compact. 5.54e+12. What is the difference between the Payments (BoP, current US$) of East Asia (all income levels) in 2010 and the Payments (BoP, current US$) of Argentina in 2011?
Keep it short and to the point. 5.44e+12. What is the difference between the Payments (BoP, current US$) in Pacific island small states in 2010 and the Payments (BoP, current US$) in Argentina in 2011?
Your answer should be compact. -9.98e+1. What is the difference between the Payments (BoP, current US$) in Central Europe in 2010 and the Payments (BoP, current US$) in East Asia (all income levels) in 2012?
Ensure brevity in your answer.  -6.29e+12. What is the difference between the Payments (BoP, current US$) of Central Europe in 2010 and the Payments (BoP, current US$) of Pacific island small states in 2012?
Give a very brief answer. 7.90e+11. What is the difference between the Payments (BoP, current US$) of Central Europe in 2010 and the Payments (BoP, current US$) of Argentina in 2012?
Provide a short and direct response. 6.97e+11. What is the difference between the Payments (BoP, current US$) of East Asia (all income levels) in 2010 and the Payments (BoP, current US$) of Pacific island small states in 2012?
Provide a short and direct response. 5.54e+12. What is the difference between the Payments (BoP, current US$) of East Asia (all income levels) in 2010 and the Payments (BoP, current US$) of Argentina in 2012?
Your response must be concise. 5.44e+12. What is the difference between the Payments (BoP, current US$) in Pacific island small states in 2010 and the Payments (BoP, current US$) in Argentina in 2012?
Provide a short and direct response. -9.37e+1. What is the difference between the Payments (BoP, current US$) of Central Europe in 2011 and the Payments (BoP, current US$) of East Asia (all income levels) in 2012?
Ensure brevity in your answer.  -6.15e+12. What is the difference between the Payments (BoP, current US$) in Central Europe in 2011 and the Payments (BoP, current US$) in Pacific island small states in 2012?
Give a very brief answer. 9.29e+11. What is the difference between the Payments (BoP, current US$) of Central Europe in 2011 and the Payments (BoP, current US$) of Argentina in 2012?
Give a very brief answer. 8.37e+11. What is the difference between the Payments (BoP, current US$) of East Asia (all income levels) in 2011 and the Payments (BoP, current US$) of Pacific island small states in 2012?
Keep it short and to the point. 6.75e+12. What is the difference between the Payments (BoP, current US$) in East Asia (all income levels) in 2011 and the Payments (BoP, current US$) in Argentina in 2012?
Ensure brevity in your answer.  6.66e+12. What is the difference between the Payments (BoP, current US$) in Pacific island small states in 2011 and the Payments (BoP, current US$) in Argentina in 2012?
Offer a terse response. -9.29e+1. What is the average Payments (BoP, current US$) of Central Europe per year?
Ensure brevity in your answer.  7.73e+11. What is the average Payments (BoP, current US$) of East Asia (all income levels) per year?
Make the answer very short. 5.04e+12. What is the average Payments (BoP, current US$) of Pacific island small states per year?
Ensure brevity in your answer.  4.55e+09. What is the average Payments (BoP, current US$) in Argentina per year?
Give a very brief answer. 7.41e+1. In the year 2005, what is the difference between the Payments (BoP, current US$) of Central Europe and Payments (BoP, current US$) of East Asia (all income levels)?
Your answer should be compact. -2.82e+12. In the year 2005, what is the difference between the Payments (BoP, current US$) of Central Europe and Payments (BoP, current US$) of Pacific island small states?
Your answer should be very brief. 4.81e+11. In the year 2005, what is the difference between the Payments (BoP, current US$) in Central Europe and Payments (BoP, current US$) in Argentina?
Provide a short and direct response. 4.39e+11. In the year 2005, what is the difference between the Payments (BoP, current US$) of East Asia (all income levels) and Payments (BoP, current US$) of Pacific island small states?
Offer a very short reply. 3.30e+12. In the year 2005, what is the difference between the Payments (BoP, current US$) of East Asia (all income levels) and Payments (BoP, current US$) of Argentina?
Offer a terse response. 3.26e+12. In the year 2005, what is the difference between the Payments (BoP, current US$) of Pacific island small states and Payments (BoP, current US$) of Argentina?
Keep it short and to the point. -4.28e+1. In the year 2006, what is the difference between the Payments (BoP, current US$) in Central Europe and Payments (BoP, current US$) in East Asia (all income levels)?
Keep it short and to the point. -3.18e+12. In the year 2006, what is the difference between the Payments (BoP, current US$) in Central Europe and Payments (BoP, current US$) in Pacific island small states?
Provide a succinct answer. 6.01e+11. In the year 2006, what is the difference between the Payments (BoP, current US$) of Central Europe and Payments (BoP, current US$) of Argentina?
Your answer should be compact. 5.52e+11. In the year 2006, what is the difference between the Payments (BoP, current US$) of East Asia (all income levels) and Payments (BoP, current US$) of Pacific island small states?
Offer a terse response. 3.78e+12. In the year 2006, what is the difference between the Payments (BoP, current US$) in East Asia (all income levels) and Payments (BoP, current US$) in Argentina?
Provide a succinct answer. 3.73e+12. In the year 2006, what is the difference between the Payments (BoP, current US$) in Pacific island small states and Payments (BoP, current US$) in Argentina?
Your answer should be very brief. -4.89e+1. In the year 2007, what is the difference between the Payments (BoP, current US$) of Central Europe and Payments (BoP, current US$) of East Asia (all income levels)?
Offer a terse response. -3.60e+12. In the year 2007, what is the difference between the Payments (BoP, current US$) in Central Europe and Payments (BoP, current US$) in Pacific island small states?
Provide a succinct answer. 7.97e+11. In the year 2007, what is the difference between the Payments (BoP, current US$) in Central Europe and Payments (BoP, current US$) in Argentina?
Your answer should be very brief. 7.35e+11. In the year 2007, what is the difference between the Payments (BoP, current US$) of East Asia (all income levels) and Payments (BoP, current US$) of Pacific island small states?
Keep it short and to the point. 4.40e+12. In the year 2007, what is the difference between the Payments (BoP, current US$) in East Asia (all income levels) and Payments (BoP, current US$) in Argentina?
Ensure brevity in your answer.  4.34e+12. In the year 2007, what is the difference between the Payments (BoP, current US$) in Pacific island small states and Payments (BoP, current US$) in Argentina?
Provide a succinct answer. -6.16e+1. In the year 2008, what is the difference between the Payments (BoP, current US$) of Central Europe and Payments (BoP, current US$) of East Asia (all income levels)?
Keep it short and to the point. -4.17e+12. In the year 2008, what is the difference between the Payments (BoP, current US$) of Central Europe and Payments (BoP, current US$) of Pacific island small states?
Ensure brevity in your answer.  9.60e+11. In the year 2008, what is the difference between the Payments (BoP, current US$) of Central Europe and Payments (BoP, current US$) of Argentina?
Make the answer very short. 8.84e+11. In the year 2008, what is the difference between the Payments (BoP, current US$) of East Asia (all income levels) and Payments (BoP, current US$) of Pacific island small states?
Your answer should be very brief. 5.13e+12. In the year 2008, what is the difference between the Payments (BoP, current US$) of East Asia (all income levels) and Payments (BoP, current US$) of Argentina?
Offer a terse response. 5.05e+12. In the year 2008, what is the difference between the Payments (BoP, current US$) of Pacific island small states and Payments (BoP, current US$) of Argentina?
Keep it short and to the point. -7.59e+1. In the year 2009, what is the difference between the Payments (BoP, current US$) of Central Europe and Payments (BoP, current US$) of East Asia (all income levels)?
Your answer should be compact. -3.57e+12. In the year 2009, what is the difference between the Payments (BoP, current US$) of Central Europe and Payments (BoP, current US$) of Pacific island small states?
Ensure brevity in your answer.  7.02e+11. In the year 2009, what is the difference between the Payments (BoP, current US$) in Central Europe and Payments (BoP, current US$) in Argentina?
Offer a terse response. 6.44e+11. In the year 2009, what is the difference between the Payments (BoP, current US$) in East Asia (all income levels) and Payments (BoP, current US$) in Pacific island small states?
Your answer should be compact. 4.27e+12. In the year 2009, what is the difference between the Payments (BoP, current US$) of East Asia (all income levels) and Payments (BoP, current US$) of Argentina?
Offer a terse response. 4.21e+12. In the year 2009, what is the difference between the Payments (BoP, current US$) of Pacific island small states and Payments (BoP, current US$) of Argentina?
Keep it short and to the point. -5.78e+1. In the year 2010, what is the difference between the Payments (BoP, current US$) of Central Europe and Payments (BoP, current US$) of East Asia (all income levels)?
Your answer should be very brief. -4.75e+12. In the year 2010, what is the difference between the Payments (BoP, current US$) in Central Europe and Payments (BoP, current US$) in Pacific island small states?
Your answer should be very brief. 7.91e+11. In the year 2010, what is the difference between the Payments (BoP, current US$) of Central Europe and Payments (BoP, current US$) of Argentina?
Offer a very short reply. 7.13e+11. In the year 2010, what is the difference between the Payments (BoP, current US$) in East Asia (all income levels) and Payments (BoP, current US$) in Pacific island small states?
Provide a short and direct response. 5.54e+12. In the year 2010, what is the difference between the Payments (BoP, current US$) in East Asia (all income levels) and Payments (BoP, current US$) in Argentina?
Make the answer very short. 5.46e+12. In the year 2010, what is the difference between the Payments (BoP, current US$) in Pacific island small states and Payments (BoP, current US$) in Argentina?
Offer a very short reply. -7.80e+1. In the year 2011, what is the difference between the Payments (BoP, current US$) of Central Europe and Payments (BoP, current US$) of East Asia (all income levels)?
Your answer should be very brief. -5.82e+12. In the year 2011, what is the difference between the Payments (BoP, current US$) in Central Europe and Payments (BoP, current US$) in Pacific island small states?
Provide a succinct answer. 9.29e+11. In the year 2011, what is the difference between the Payments (BoP, current US$) in Central Europe and Payments (BoP, current US$) in Argentina?
Your response must be concise. 8.30e+11. In the year 2011, what is the difference between the Payments (BoP, current US$) of East Asia (all income levels) and Payments (BoP, current US$) of Pacific island small states?
Provide a short and direct response. 6.75e+12. In the year 2011, what is the difference between the Payments (BoP, current US$) of East Asia (all income levels) and Payments (BoP, current US$) of Argentina?
Offer a very short reply. 6.65e+12. In the year 2011, what is the difference between the Payments (BoP, current US$) of Pacific island small states and Payments (BoP, current US$) of Argentina?
Your answer should be compact. -9.90e+1. In the year 2012, what is the difference between the Payments (BoP, current US$) in Central Europe and Payments (BoP, current US$) in East Asia (all income levels)?
Your response must be concise. -6.20e+12. In the year 2012, what is the difference between the Payments (BoP, current US$) of Central Europe and Payments (BoP, current US$) of Pacific island small states?
Your answer should be very brief. 8.86e+11. In the year 2012, what is the difference between the Payments (BoP, current US$) of Central Europe and Payments (BoP, current US$) of Argentina?
Your answer should be compact. 7.93e+11. In the year 2012, what is the difference between the Payments (BoP, current US$) of East Asia (all income levels) and Payments (BoP, current US$) of Pacific island small states?
Keep it short and to the point. 7.08e+12. In the year 2012, what is the difference between the Payments (BoP, current US$) in East Asia (all income levels) and Payments (BoP, current US$) in Argentina?
Provide a short and direct response. 6.99e+12. In the year 2012, what is the difference between the Payments (BoP, current US$) of Pacific island small states and Payments (BoP, current US$) of Argentina?
Give a very brief answer. -9.27e+1. What is the ratio of the Payments (BoP, current US$) of Central Europe in 2005 to that in 2006?
Keep it short and to the point. 0.8. What is the ratio of the Payments (BoP, current US$) in East Asia (all income levels) in 2005 to that in 2006?
Your response must be concise. 0.87. What is the ratio of the Payments (BoP, current US$) of Pacific island small states in 2005 to that in 2006?
Offer a very short reply. 0.91. What is the ratio of the Payments (BoP, current US$) of Argentina in 2005 to that in 2006?
Offer a very short reply. 0.88. What is the ratio of the Payments (BoP, current US$) of Central Europe in 2005 to that in 2007?
Keep it short and to the point. 0.61. What is the ratio of the Payments (BoP, current US$) in East Asia (all income levels) in 2005 to that in 2007?
Make the answer very short. 0.75. What is the ratio of the Payments (BoP, current US$) of Pacific island small states in 2005 to that in 2007?
Provide a succinct answer. 0.85. What is the ratio of the Payments (BoP, current US$) of Argentina in 2005 to that in 2007?
Provide a succinct answer. 0.71. What is the ratio of the Payments (BoP, current US$) of Central Europe in 2005 to that in 2008?
Your answer should be very brief. 0.5. What is the ratio of the Payments (BoP, current US$) of East Asia (all income levels) in 2005 to that in 2008?
Provide a short and direct response. 0.64. What is the ratio of the Payments (BoP, current US$) of Pacific island small states in 2005 to that in 2008?
Offer a terse response. 0.69. What is the ratio of the Payments (BoP, current US$) of Argentina in 2005 to that in 2008?
Your answer should be very brief. 0.57. What is the ratio of the Payments (BoP, current US$) in Central Europe in 2005 to that in 2009?
Ensure brevity in your answer.  0.69. What is the ratio of the Payments (BoP, current US$) of East Asia (all income levels) in 2005 to that in 2009?
Keep it short and to the point. 0.77. What is the ratio of the Payments (BoP, current US$) in Pacific island small states in 2005 to that in 2009?
Your answer should be very brief. 0.93. What is the ratio of the Payments (BoP, current US$) in Argentina in 2005 to that in 2009?
Your response must be concise. 0.75. What is the ratio of the Payments (BoP, current US$) of Central Europe in 2005 to that in 2010?
Keep it short and to the point. 0.61. What is the ratio of the Payments (BoP, current US$) of East Asia (all income levels) in 2005 to that in 2010?
Your response must be concise. 0.6. What is the ratio of the Payments (BoP, current US$) of Pacific island small states in 2005 to that in 2010?
Keep it short and to the point. 0.78. What is the ratio of the Payments (BoP, current US$) in Argentina in 2005 to that in 2010?
Keep it short and to the point. 0.56. What is the ratio of the Payments (BoP, current US$) in Central Europe in 2005 to that in 2011?
Keep it short and to the point. 0.52. What is the ratio of the Payments (BoP, current US$) of East Asia (all income levels) in 2005 to that in 2011?
Provide a succinct answer. 0.49. What is the ratio of the Payments (BoP, current US$) in Pacific island small states in 2005 to that in 2011?
Keep it short and to the point. 0.66. What is the ratio of the Payments (BoP, current US$) in Argentina in 2005 to that in 2011?
Ensure brevity in your answer.  0.44. What is the ratio of the Payments (BoP, current US$) in Central Europe in 2005 to that in 2012?
Give a very brief answer. 0.54. What is the ratio of the Payments (BoP, current US$) of East Asia (all income levels) in 2005 to that in 2012?
Offer a terse response. 0.47. What is the ratio of the Payments (BoP, current US$) of Pacific island small states in 2005 to that in 2012?
Make the answer very short. 0.64. What is the ratio of the Payments (BoP, current US$) of Argentina in 2005 to that in 2012?
Your answer should be compact. 0.47. What is the ratio of the Payments (BoP, current US$) of Central Europe in 2006 to that in 2007?
Provide a short and direct response. 0.76. What is the ratio of the Payments (BoP, current US$) in East Asia (all income levels) in 2006 to that in 2007?
Provide a succinct answer. 0.86. What is the ratio of the Payments (BoP, current US$) of Pacific island small states in 2006 to that in 2007?
Keep it short and to the point. 0.94. What is the ratio of the Payments (BoP, current US$) in Argentina in 2006 to that in 2007?
Ensure brevity in your answer.  0.8. What is the ratio of the Payments (BoP, current US$) of Central Europe in 2006 to that in 2008?
Give a very brief answer. 0.63. What is the ratio of the Payments (BoP, current US$) of East Asia (all income levels) in 2006 to that in 2008?
Your answer should be compact. 0.74. What is the ratio of the Payments (BoP, current US$) of Pacific island small states in 2006 to that in 2008?
Keep it short and to the point. 0.76. What is the ratio of the Payments (BoP, current US$) in Argentina in 2006 to that in 2008?
Make the answer very short. 0.65. What is the ratio of the Payments (BoP, current US$) of Central Europe in 2006 to that in 2009?
Your answer should be compact. 0.86. What is the ratio of the Payments (BoP, current US$) in East Asia (all income levels) in 2006 to that in 2009?
Provide a short and direct response. 0.89. What is the ratio of the Payments (BoP, current US$) in Pacific island small states in 2006 to that in 2009?
Provide a succinct answer. 1.02. What is the ratio of the Payments (BoP, current US$) in Argentina in 2006 to that in 2009?
Your answer should be very brief. 0.86. What is the ratio of the Payments (BoP, current US$) of Central Europe in 2006 to that in 2010?
Your answer should be very brief. 0.76. What is the ratio of the Payments (BoP, current US$) of East Asia (all income levels) in 2006 to that in 2010?
Ensure brevity in your answer.  0.68. What is the ratio of the Payments (BoP, current US$) of Pacific island small states in 2006 to that in 2010?
Provide a succinct answer. 0.85. What is the ratio of the Payments (BoP, current US$) in Argentina in 2006 to that in 2010?
Ensure brevity in your answer.  0.64. What is the ratio of the Payments (BoP, current US$) of Central Europe in 2006 to that in 2011?
Provide a short and direct response. 0.65. What is the ratio of the Payments (BoP, current US$) of East Asia (all income levels) in 2006 to that in 2011?
Ensure brevity in your answer.  0.56. What is the ratio of the Payments (BoP, current US$) in Pacific island small states in 2006 to that in 2011?
Offer a terse response. 0.73. What is the ratio of the Payments (BoP, current US$) in Argentina in 2006 to that in 2011?
Provide a short and direct response. 0.51. What is the ratio of the Payments (BoP, current US$) in Central Europe in 2006 to that in 2012?
Give a very brief answer. 0.68. What is the ratio of the Payments (BoP, current US$) in East Asia (all income levels) in 2006 to that in 2012?
Give a very brief answer. 0.53. What is the ratio of the Payments (BoP, current US$) in Pacific island small states in 2006 to that in 2012?
Provide a short and direct response. 0.7. What is the ratio of the Payments (BoP, current US$) of Argentina in 2006 to that in 2012?
Your answer should be compact. 0.54. What is the ratio of the Payments (BoP, current US$) of Central Europe in 2007 to that in 2008?
Give a very brief answer. 0.83. What is the ratio of the Payments (BoP, current US$) of East Asia (all income levels) in 2007 to that in 2008?
Make the answer very short. 0.86. What is the ratio of the Payments (BoP, current US$) in Pacific island small states in 2007 to that in 2008?
Offer a very short reply. 0.81. What is the ratio of the Payments (BoP, current US$) in Argentina in 2007 to that in 2008?
Your response must be concise. 0.81. What is the ratio of the Payments (BoP, current US$) of Central Europe in 2007 to that in 2009?
Your answer should be very brief. 1.13. What is the ratio of the Payments (BoP, current US$) of East Asia (all income levels) in 2007 to that in 2009?
Offer a terse response. 1.03. What is the ratio of the Payments (BoP, current US$) of Pacific island small states in 2007 to that in 2009?
Your response must be concise. 1.09. What is the ratio of the Payments (BoP, current US$) in Argentina in 2007 to that in 2009?
Give a very brief answer. 1.07. What is the ratio of the Payments (BoP, current US$) of Central Europe in 2007 to that in 2010?
Your answer should be compact. 1.01. What is the ratio of the Payments (BoP, current US$) in East Asia (all income levels) in 2007 to that in 2010?
Your answer should be compact. 0.79. What is the ratio of the Payments (BoP, current US$) in Pacific island small states in 2007 to that in 2010?
Keep it short and to the point. 0.91. What is the ratio of the Payments (BoP, current US$) of Argentina in 2007 to that in 2010?
Offer a very short reply. 0.8. What is the ratio of the Payments (BoP, current US$) of Central Europe in 2007 to that in 2011?
Give a very brief answer. 0.86. What is the ratio of the Payments (BoP, current US$) in East Asia (all income levels) in 2007 to that in 2011?
Keep it short and to the point. 0.65. What is the ratio of the Payments (BoP, current US$) in Pacific island small states in 2007 to that in 2011?
Ensure brevity in your answer.  0.77. What is the ratio of the Payments (BoP, current US$) in Argentina in 2007 to that in 2011?
Offer a very short reply. 0.63. What is the ratio of the Payments (BoP, current US$) in Central Europe in 2007 to that in 2012?
Provide a succinct answer. 0.9. What is the ratio of the Payments (BoP, current US$) in East Asia (all income levels) in 2007 to that in 2012?
Offer a terse response. 0.62. What is the ratio of the Payments (BoP, current US$) of Pacific island small states in 2007 to that in 2012?
Offer a very short reply. 0.75. What is the ratio of the Payments (BoP, current US$) in Argentina in 2007 to that in 2012?
Offer a very short reply. 0.67. What is the ratio of the Payments (BoP, current US$) of Central Europe in 2008 to that in 2009?
Offer a terse response. 1.37. What is the ratio of the Payments (BoP, current US$) of East Asia (all income levels) in 2008 to that in 2009?
Your answer should be very brief. 1.2. What is the ratio of the Payments (BoP, current US$) in Pacific island small states in 2008 to that in 2009?
Provide a short and direct response. 1.34. What is the ratio of the Payments (BoP, current US$) of Argentina in 2008 to that in 2009?
Make the answer very short. 1.31. What is the ratio of the Payments (BoP, current US$) of Central Europe in 2008 to that in 2010?
Your answer should be compact. 1.21. What is the ratio of the Payments (BoP, current US$) in East Asia (all income levels) in 2008 to that in 2010?
Keep it short and to the point. 0.93. What is the ratio of the Payments (BoP, current US$) of Pacific island small states in 2008 to that in 2010?
Provide a succinct answer. 1.12. What is the ratio of the Payments (BoP, current US$) in Argentina in 2008 to that in 2010?
Your answer should be compact. 0.98. What is the ratio of the Payments (BoP, current US$) in Central Europe in 2008 to that in 2011?
Give a very brief answer. 1.03. What is the ratio of the Payments (BoP, current US$) of East Asia (all income levels) in 2008 to that in 2011?
Make the answer very short. 0.76. What is the ratio of the Payments (BoP, current US$) in Pacific island small states in 2008 to that in 2011?
Your answer should be compact. 0.95. What is the ratio of the Payments (BoP, current US$) in Argentina in 2008 to that in 2011?
Keep it short and to the point. 0.78. What is the ratio of the Payments (BoP, current US$) of Central Europe in 2008 to that in 2012?
Your answer should be very brief. 1.08. What is the ratio of the Payments (BoP, current US$) in East Asia (all income levels) in 2008 to that in 2012?
Ensure brevity in your answer.  0.72. What is the ratio of the Payments (BoP, current US$) of Pacific island small states in 2008 to that in 2012?
Offer a terse response. 0.92. What is the ratio of the Payments (BoP, current US$) in Argentina in 2008 to that in 2012?
Give a very brief answer. 0.82. What is the ratio of the Payments (BoP, current US$) of Central Europe in 2009 to that in 2010?
Provide a succinct answer. 0.89. What is the ratio of the Payments (BoP, current US$) of East Asia (all income levels) in 2009 to that in 2010?
Give a very brief answer. 0.77. What is the ratio of the Payments (BoP, current US$) in Pacific island small states in 2009 to that in 2010?
Keep it short and to the point. 0.84. What is the ratio of the Payments (BoP, current US$) of Argentina in 2009 to that in 2010?
Your response must be concise. 0.75. What is the ratio of the Payments (BoP, current US$) in Central Europe in 2009 to that in 2011?
Ensure brevity in your answer.  0.75. What is the ratio of the Payments (BoP, current US$) in East Asia (all income levels) in 2009 to that in 2011?
Keep it short and to the point. 0.63. What is the ratio of the Payments (BoP, current US$) of Pacific island small states in 2009 to that in 2011?
Make the answer very short. 0.71. What is the ratio of the Payments (BoP, current US$) of Argentina in 2009 to that in 2011?
Your answer should be very brief. 0.59. What is the ratio of the Payments (BoP, current US$) in Central Europe in 2009 to that in 2012?
Offer a very short reply. 0.79. What is the ratio of the Payments (BoP, current US$) of East Asia (all income levels) in 2009 to that in 2012?
Offer a very short reply. 0.6. What is the ratio of the Payments (BoP, current US$) of Pacific island small states in 2009 to that in 2012?
Your answer should be very brief. 0.69. What is the ratio of the Payments (BoP, current US$) in Argentina in 2009 to that in 2012?
Give a very brief answer. 0.63. What is the ratio of the Payments (BoP, current US$) of Central Europe in 2010 to that in 2011?
Your response must be concise. 0.85. What is the ratio of the Payments (BoP, current US$) of East Asia (all income levels) in 2010 to that in 2011?
Provide a succinct answer. 0.82. What is the ratio of the Payments (BoP, current US$) of Pacific island small states in 2010 to that in 2011?
Offer a terse response. 0.85. What is the ratio of the Payments (BoP, current US$) in Argentina in 2010 to that in 2011?
Make the answer very short. 0.79. What is the ratio of the Payments (BoP, current US$) of Central Europe in 2010 to that in 2012?
Provide a succinct answer. 0.89. What is the ratio of the Payments (BoP, current US$) of East Asia (all income levels) in 2010 to that in 2012?
Your answer should be very brief. 0.78. What is the ratio of the Payments (BoP, current US$) of Pacific island small states in 2010 to that in 2012?
Your answer should be compact. 0.83. What is the ratio of the Payments (BoP, current US$) in Argentina in 2010 to that in 2012?
Your response must be concise. 0.84. What is the ratio of the Payments (BoP, current US$) of Central Europe in 2011 to that in 2012?
Give a very brief answer. 1.05. What is the ratio of the Payments (BoP, current US$) of East Asia (all income levels) in 2011 to that in 2012?
Make the answer very short. 0.95. What is the ratio of the Payments (BoP, current US$) of Pacific island small states in 2011 to that in 2012?
Ensure brevity in your answer.  0.97. What is the ratio of the Payments (BoP, current US$) in Argentina in 2011 to that in 2012?
Provide a succinct answer. 1.06. What is the difference between the highest and the second highest Payments (BoP, current US$) in Central Europe?
Offer a terse response. 3.06e+1. What is the difference between the highest and the second highest Payments (BoP, current US$) of East Asia (all income levels)?
Your answer should be compact. 3.35e+11. What is the difference between the highest and the second highest Payments (BoP, current US$) in Pacific island small states?
Offer a terse response. 1.75e+08. What is the difference between the highest and the second highest Payments (BoP, current US$) in Argentina?
Ensure brevity in your answer.  6.14e+09. What is the difference between the highest and the lowest Payments (BoP, current US$) of Central Europe?
Offer a terse response. 4.80e+11. What is the difference between the highest and the lowest Payments (BoP, current US$) of East Asia (all income levels)?
Keep it short and to the point. 3.78e+12. What is the difference between the highest and the lowest Payments (BoP, current US$) of Pacific island small states?
Your answer should be compact. 2.02e+09. What is the difference between the highest and the lowest Payments (BoP, current US$) of Argentina?
Provide a short and direct response. 5.80e+1. 